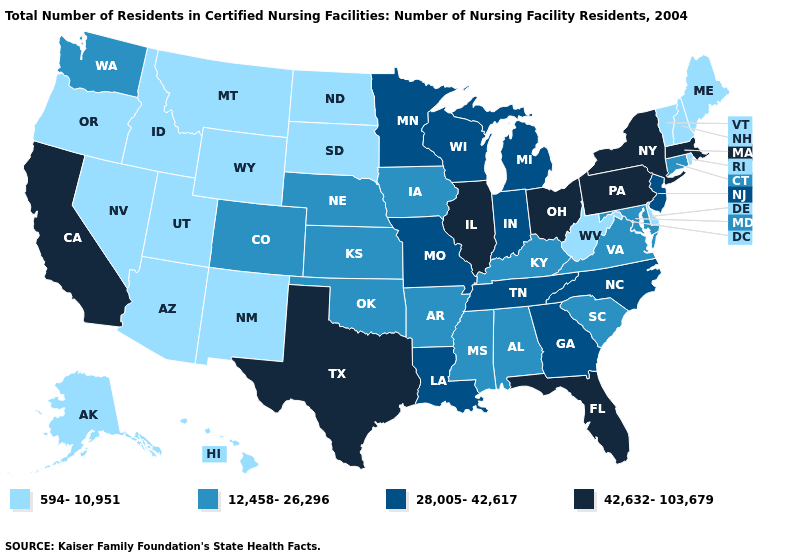Does the first symbol in the legend represent the smallest category?
Keep it brief. Yes. Does Iowa have the highest value in the MidWest?
Keep it brief. No. Which states have the highest value in the USA?
Give a very brief answer. California, Florida, Illinois, Massachusetts, New York, Ohio, Pennsylvania, Texas. Which states hav the highest value in the MidWest?
Concise answer only. Illinois, Ohio. Which states hav the highest value in the West?
Keep it brief. California. What is the highest value in the South ?
Quick response, please. 42,632-103,679. Name the states that have a value in the range 594-10,951?
Short answer required. Alaska, Arizona, Delaware, Hawaii, Idaho, Maine, Montana, Nevada, New Hampshire, New Mexico, North Dakota, Oregon, Rhode Island, South Dakota, Utah, Vermont, West Virginia, Wyoming. What is the value of Kansas?
Answer briefly. 12,458-26,296. Does the map have missing data?
Quick response, please. No. Does California have the highest value in the West?
Quick response, please. Yes. Does Texas have the highest value in the South?
Write a very short answer. Yes. Which states have the highest value in the USA?
Write a very short answer. California, Florida, Illinois, Massachusetts, New York, Ohio, Pennsylvania, Texas. Does Missouri have the same value as Minnesota?
Quick response, please. Yes. What is the highest value in the USA?
Give a very brief answer. 42,632-103,679. Among the states that border Wisconsin , which have the highest value?
Give a very brief answer. Illinois. 